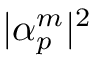Convert formula to latex. <formula><loc_0><loc_0><loc_500><loc_500>| \alpha _ { p } ^ { m } | ^ { 2 }</formula> 